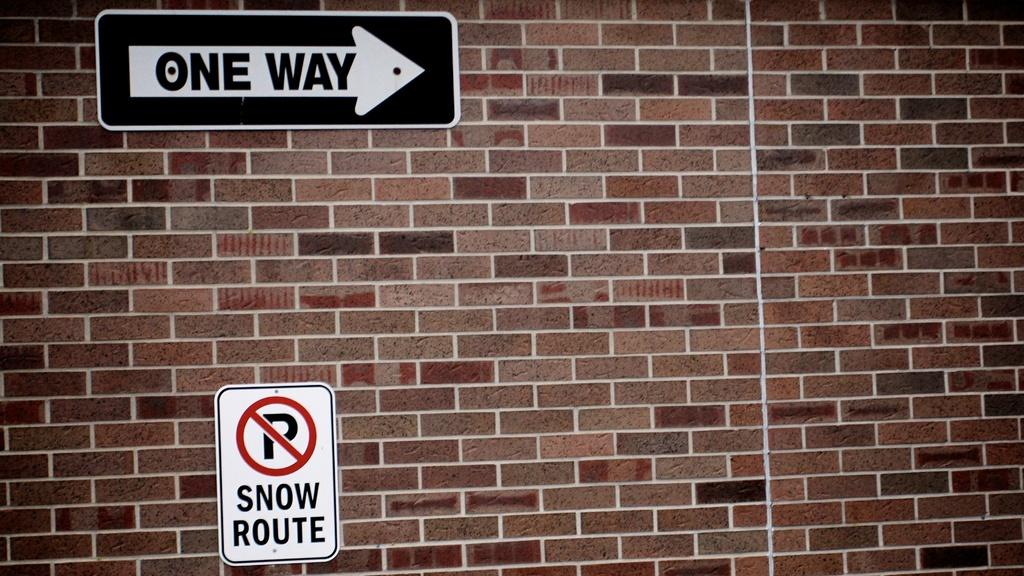<image>
Offer a succinct explanation of the picture presented. Signs on a brick wall show One Way and No Parking Snow Route. 